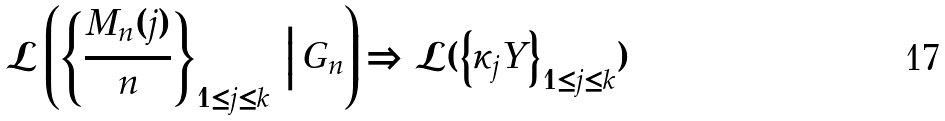<formula> <loc_0><loc_0><loc_500><loc_500>\mathcal { L } \left ( \left \{ \frac { M _ { n } ( j ) } { n } \right \} _ { 1 \leq j \leq k } \, \Big | \, G _ { n } \right ) \Longrightarrow \mathcal { L } ( \left \{ \kappa _ { j } Y \right \} _ { 1 \leq j \leq k } )</formula> 